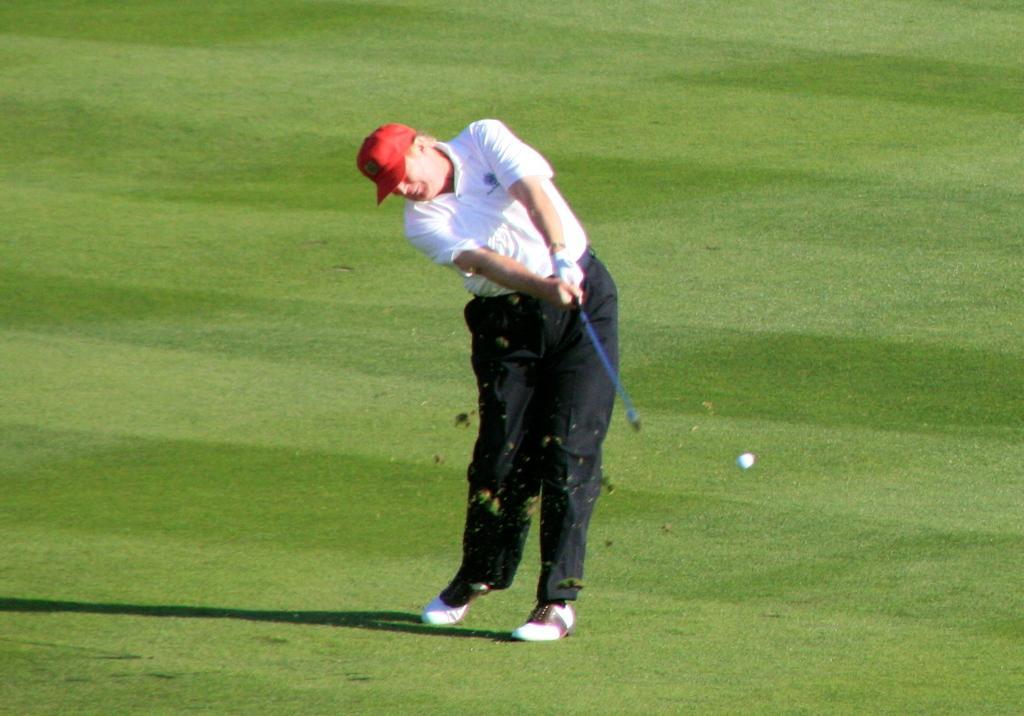In one or two sentences, can you explain what this image depicts? In this image, we can see a person holding an object. We can see the ground covered with grass. We can also see a ball and the shadow on the ground. 